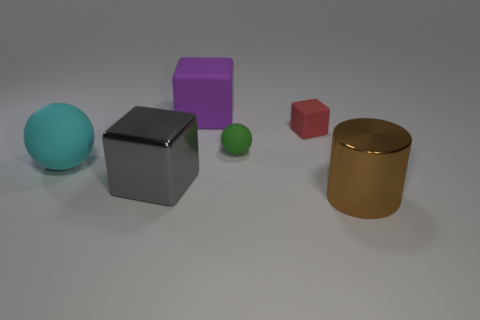What are the materials the objects appear to be made of? The objects display a variety of materials. The big rubber cube has a matte finish, suggesting a rubber-like material. The large teal sphere and the small green sphere both have a smooth surface, indicating they might be plastic or glass. The purple cube has a slight sheen and may be made of shiny plastic or metal, while the small red cube seems matte, similar to rubber or dull plastic. Lastly, the golden cylinder has a reflective surface that suggests it's metallic. 